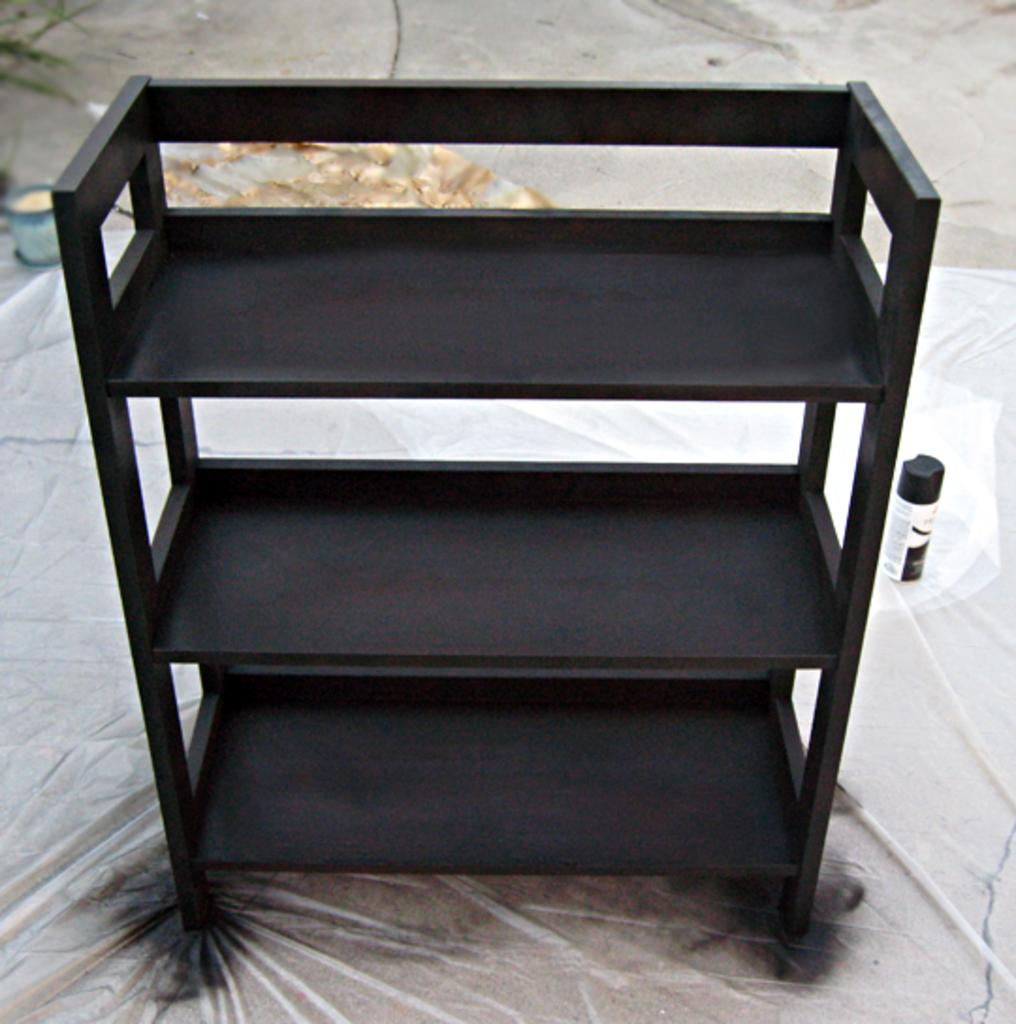What is the main object in the image? There is a black color rack in the image. What is the rack placed on? The rack is on a plastic cover. What other item can be seen in the image? There is a black and white color bottle in the image. Where is the bottle located in relation to the rack? The bottle is beside the rack. What type of boats are celebrating a birthday in the image? There are no boats or birthday celebrations present in the image. 